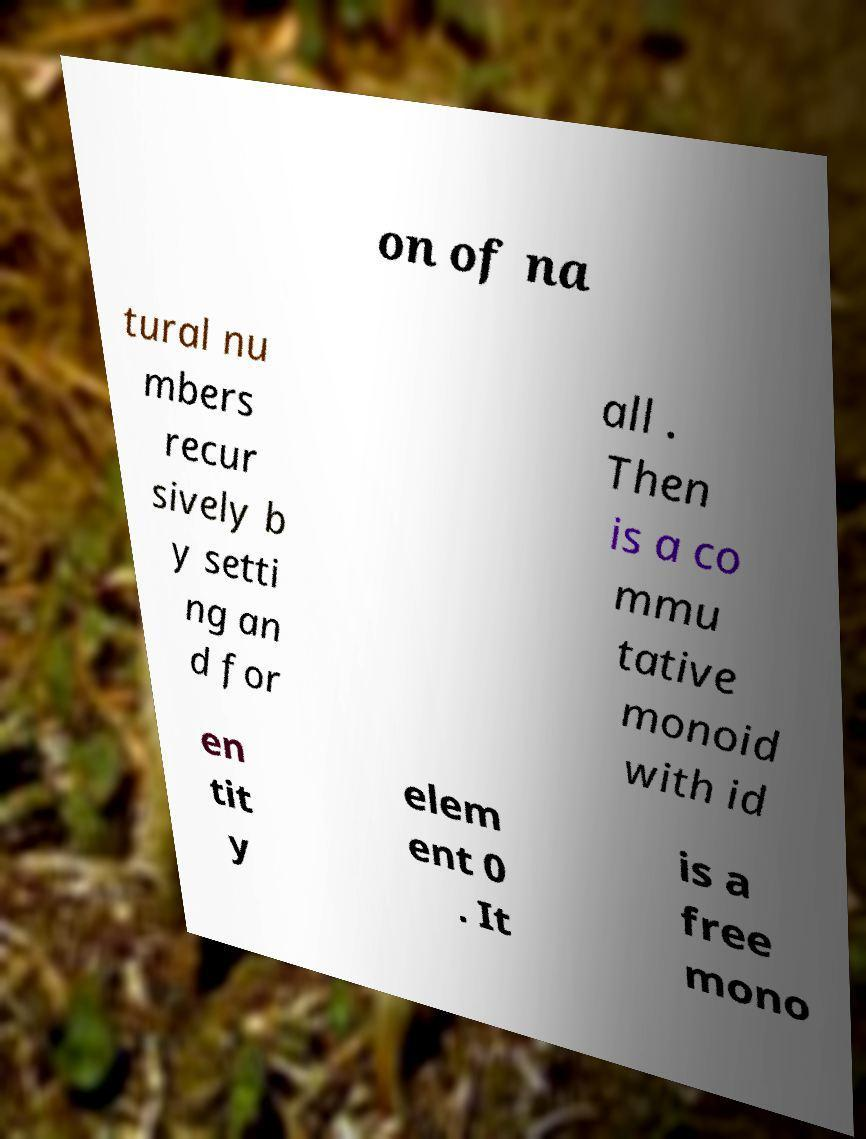Please read and relay the text visible in this image. What does it say? on of na tural nu mbers recur sively b y setti ng an d for all . Then is a co mmu tative monoid with id en tit y elem ent 0 . It is a free mono 